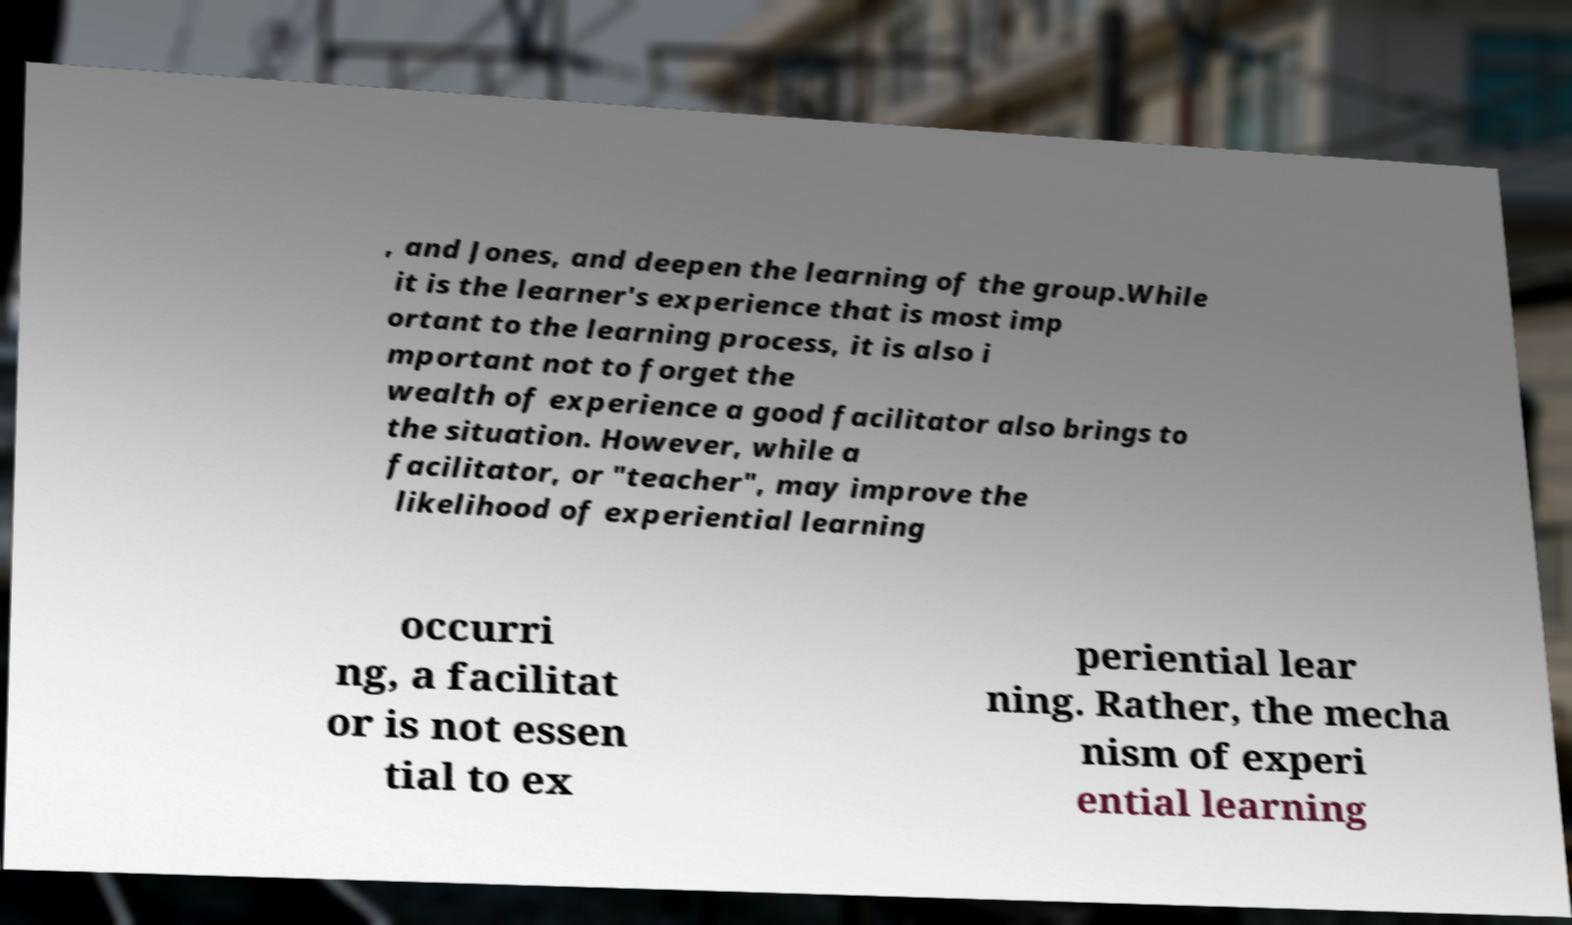Can you accurately transcribe the text from the provided image for me? , and Jones, and deepen the learning of the group.While it is the learner's experience that is most imp ortant to the learning process, it is also i mportant not to forget the wealth of experience a good facilitator also brings to the situation. However, while a facilitator, or "teacher", may improve the likelihood of experiential learning occurri ng, a facilitat or is not essen tial to ex periential lear ning. Rather, the mecha nism of experi ential learning 